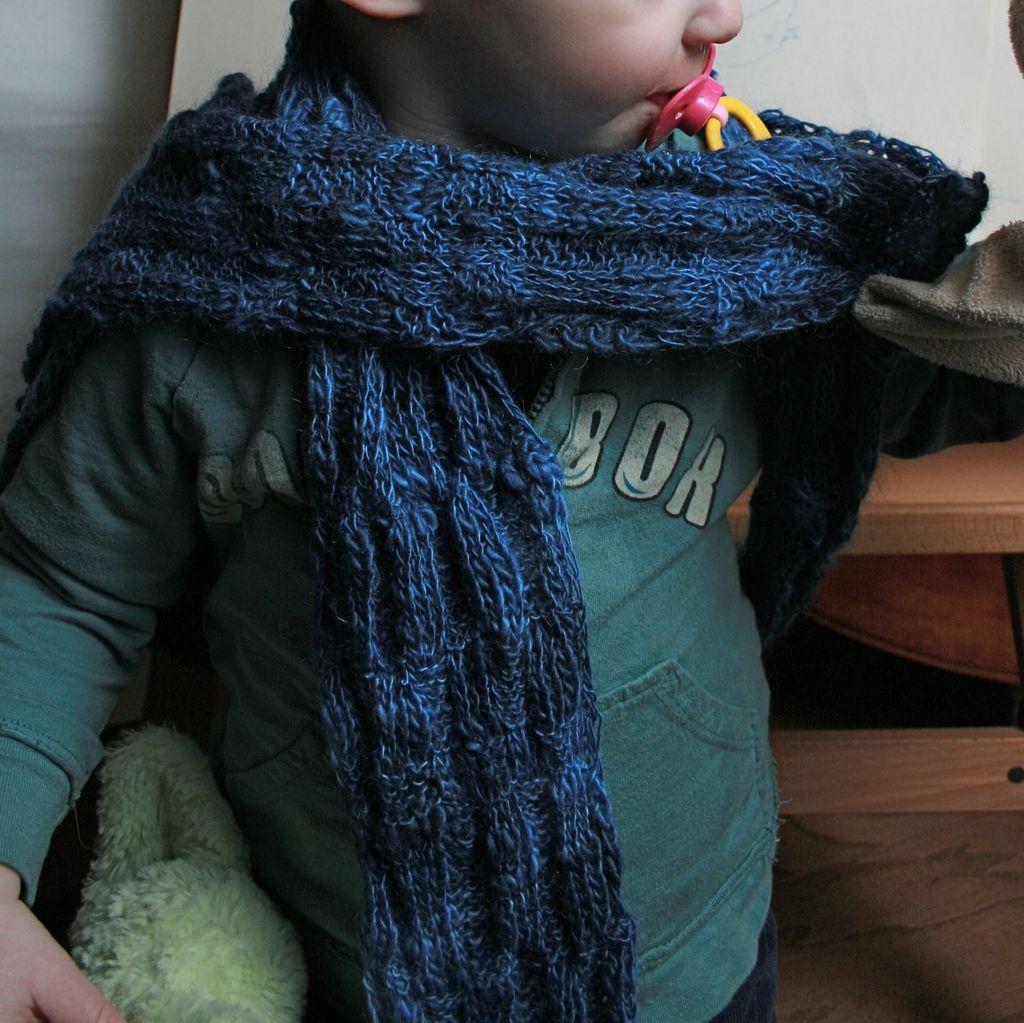How would you summarize this image in a sentence or two? In this image we can see one truncated child standing on the floor, holding on object and one object in the child's mouth. There are few objects in the background and two objects on the right side of the image. 